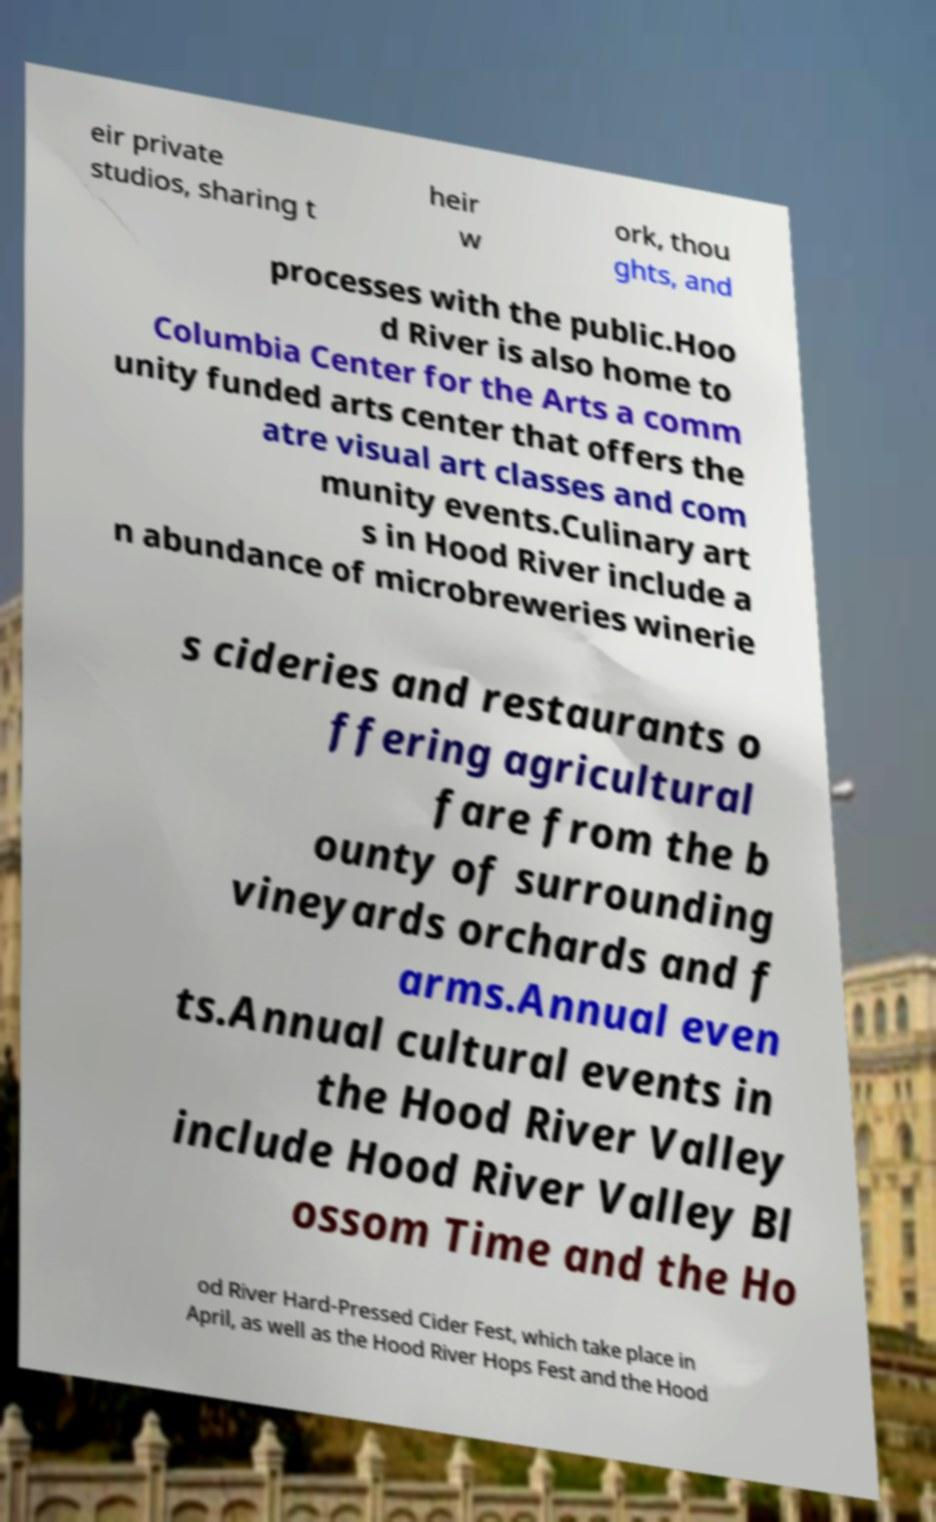I need the written content from this picture converted into text. Can you do that? eir private studios, sharing t heir w ork, thou ghts, and processes with the public.Hoo d River is also home to Columbia Center for the Arts a comm unity funded arts center that offers the atre visual art classes and com munity events.Culinary art s in Hood River include a n abundance of microbreweries winerie s cideries and restaurants o ffering agricultural fare from the b ounty of surrounding vineyards orchards and f arms.Annual even ts.Annual cultural events in the Hood River Valley include Hood River Valley Bl ossom Time and the Ho od River Hard-Pressed Cider Fest, which take place in April, as well as the Hood River Hops Fest and the Hood 